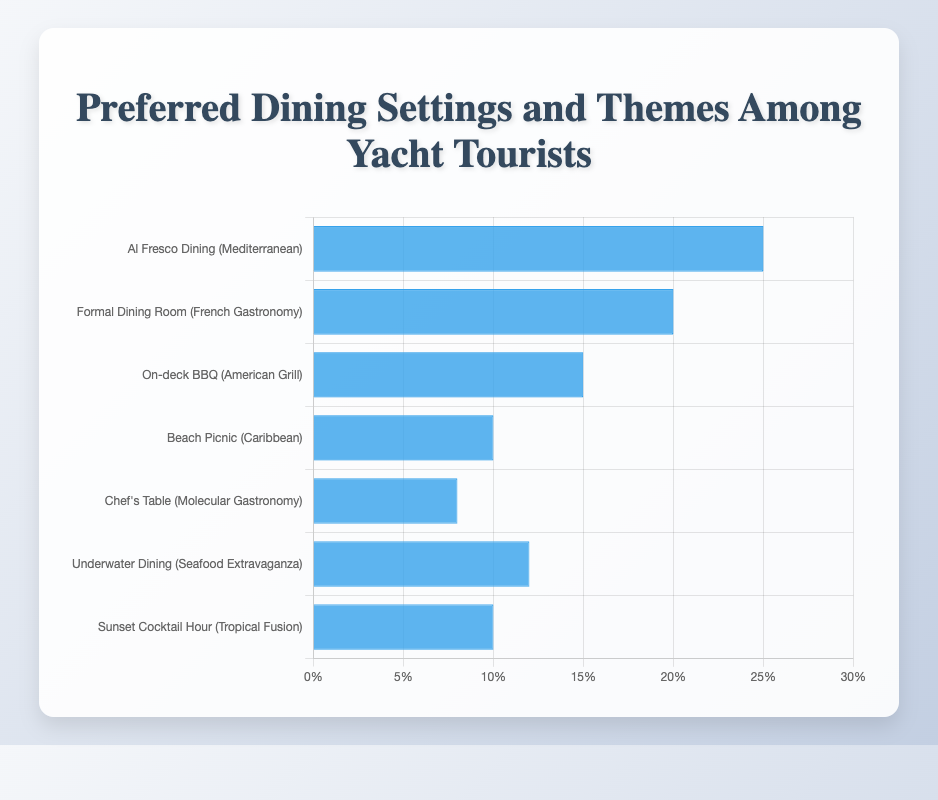What dining setting and theme combination is the most preferred among yacht tourists? The figure shows the most preferred dining setting and theme combination by the highest bar. The "Al Fresco Dining (Mediterranean)" bar is the tallest, indicating it is the most preferred.
Answer: Al Fresco Dining (Mediterranean) Which dining setting and theme combination is the least preferred by yacht tourists? The least preferred combination is represented by the shortest bar in the chart. The "Chef's Table (Molecular Gastronomy)" bar is the shortest, indicating it is the least preferred.
Answer: Chef's Table (Molecular Gastronomy) How many percentages more do tourists prefer Al Fresco Dining (Mediterranean) over Chef's Table (Molecular Gastronomy)? To find this, subtract the Chef's Table percentage from the Al Fresco Dining percentage: 25% - 8% = 17%.
Answer: 17% What are the total percentages of tourists who prefer Beach Picnic, Sunset Cocktail Hour, and Underwater Dining combined? Sum the percentages of Beach Picnic, Sunset Cocktail Hour, and Underwater Dining: 10% + 10% + 12% = 32%.
Answer: 32% Which setting and theme combination is preferred by 20% of yacht tourists? According to the figure, "Formal Dining Room (French Gastronomy)" has a bar that corresponds to 20%.
Answer: Formal Dining Room (French Gastronomy) How does the percentage of tourists who prefer On-deck BBQ (American Grill) compare to those who prefer Sunset Cocktail Hour (Tropical Fusion)? The On-deck BBQ (American Grill) is preferred by 15% and Sunset Cocktail Hour by 10%. Thus, On-deck BBQ is preferred 5% more than Sunset Cocktail Hour.
Answer: On-deck BBQ (American Grill) preferred by 5% more What setting and theme combination corresponds to the bar that is 12 units high in percentage? The bar with a height of 12 units in percentage represents "Underwater Dining (Seafood Extravaganza)".
Answer: Underwater Dining (Seafood Extravaganza) What is the difference in preference between Formal Dining Room (French Gastronomy) and Underwater Dining (Seafood Extravaganza)? Subtract the percentage of Underwater Dining from Formal Dining Room: 20% - 12% = 8%.
Answer: 8% What is the median value of the dining preferences percentages? The percentages in ascending order are: 8%, 10%, 10%, 12%, 15%, 20%, 25%. The median value is the middle one, which is 12%.
Answer: 12% Which two dining settings and themes have an equal percentage of tourist preferences? According to the figure, "Beach Picnic (Caribbean)" and "Sunset Cocktail Hour (Tropical Fusion)" both have bars corresponding to 10%.
Answer: Beach Picnic (Caribbean) and Sunset Cocktail Hour (Tropical Fusion) 